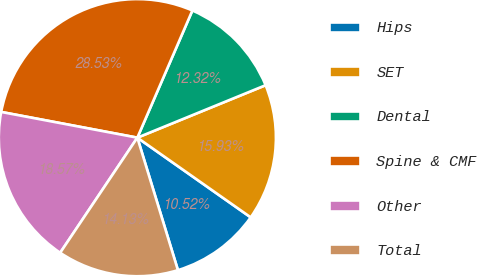<chart> <loc_0><loc_0><loc_500><loc_500><pie_chart><fcel>Hips<fcel>SET<fcel>Dental<fcel>Spine & CMF<fcel>Other<fcel>Total<nl><fcel>10.52%<fcel>15.93%<fcel>12.32%<fcel>28.53%<fcel>18.57%<fcel>14.13%<nl></chart> 